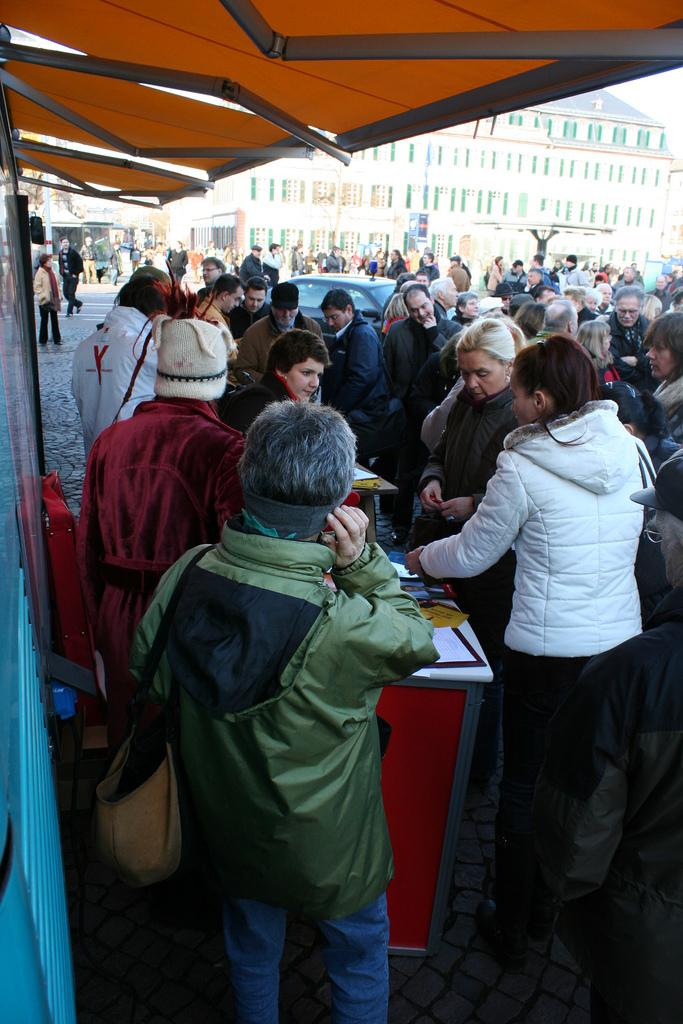What is the main focus of the image? The main focus of the image is the persons in the center. What type of vehicle is present in the image? There is a black car in the image. What can be seen in the background of the image? There are buildings in the background of the image. What is located in the front of the image, on the top? There is a tent in the front of the image, on the top. What type of attraction is present in the image? There is no attraction present in the image; it features persons, a black car, buildings, and a tent. What feeling is being expressed by the persons in the image? The image does not convey any specific feelings or emotions of the persons; it only shows their presence and positioning. 